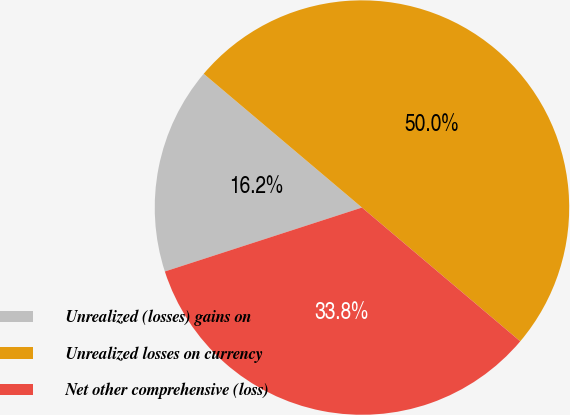Convert chart. <chart><loc_0><loc_0><loc_500><loc_500><pie_chart><fcel>Unrealized (losses) gains on<fcel>Unrealized losses on currency<fcel>Net other comprehensive (loss)<nl><fcel>16.16%<fcel>50.0%<fcel>33.84%<nl></chart> 